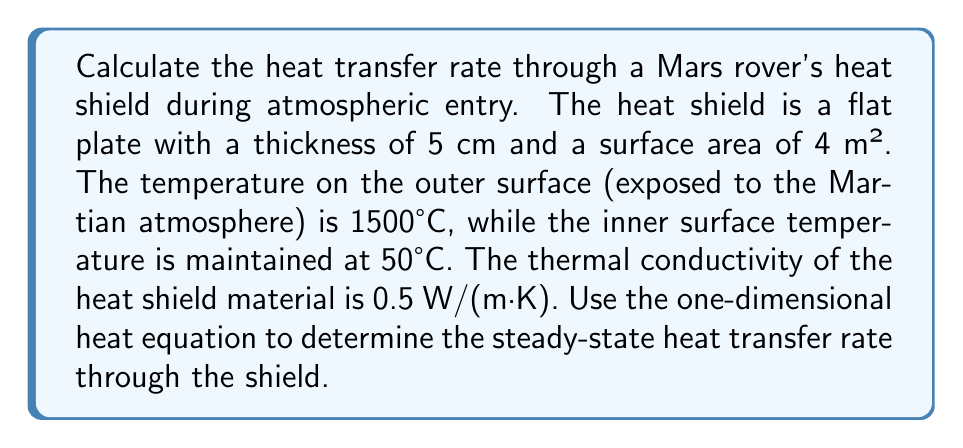Give your solution to this math problem. To solve this problem, we'll use Fourier's law of heat conduction in one dimension, which is a simplified form of the heat equation for steady-state conditions.

1. The one-dimensional heat equation for steady-state conditions is:

   $$\frac{d^2T}{dx^2} = 0$$

2. The general solution to this equation is:

   $$T(x) = C_1x + C_2$$

   where $C_1$ and $C_2$ are constants determined by the boundary conditions.

3. Boundary conditions:
   - At $x = 0$ (outer surface): $T(0) = 1500°C$
   - At $x = L$ (inner surface): $T(L) = 50°C$, where $L = 0.05$ m (shield thickness)

4. Applying these boundary conditions:

   $$T(0) = C_2 = 1500°C$$
   $$T(L) = C_1L + C_2 = 50°C$$

5. Solving for $C_1$:

   $$C_1 = \frac{50°C - 1500°C}{0.05 \text{ m}} = -29,000 \text{ °C/m}$$

6. The temperature distribution is thus:

   $$T(x) = -29,000x + 1500$$

7. The heat flux is given by Fourier's law:

   $$q = -k\frac{dT}{dx}$$

   where $k$ is the thermal conductivity.

8. Calculating the heat flux:

   $$q = -0.5 \text{ W/(m·K)} \cdot (-29,000 \text{ °C/m}) = 14,500 \text{ W/m²}$$

9. The total heat transfer rate is the heat flux multiplied by the area:

   $$Q = qA = 14,500 \text{ W/m²} \cdot 4 \text{ m²} = 58,000 \text{ W}$$
Answer: The steady-state heat transfer rate through the Mars rover's heat shield during atmospheric entry is 58,000 W or 58 kW. 